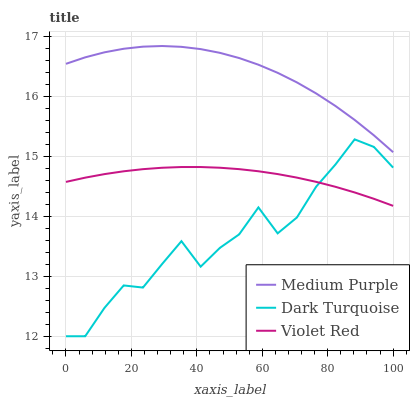Does Violet Red have the minimum area under the curve?
Answer yes or no. No. Does Violet Red have the maximum area under the curve?
Answer yes or no. No. Is Dark Turquoise the smoothest?
Answer yes or no. No. Is Violet Red the roughest?
Answer yes or no. No. Does Violet Red have the lowest value?
Answer yes or no. No. Does Dark Turquoise have the highest value?
Answer yes or no. No. Is Dark Turquoise less than Medium Purple?
Answer yes or no. Yes. Is Medium Purple greater than Dark Turquoise?
Answer yes or no. Yes. Does Dark Turquoise intersect Medium Purple?
Answer yes or no. No. 